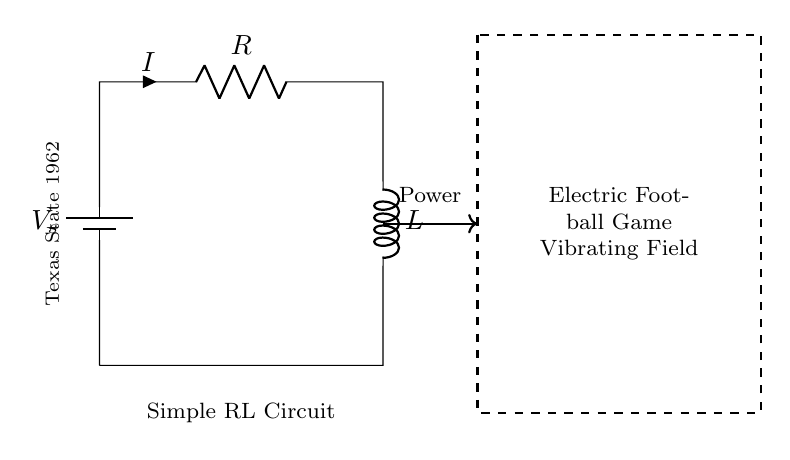What type of components are in this circuit? The circuit contains a resistor and an inductor, which are indicated by the symbols "R" and "L" respectively.
Answer: Resistor and Inductor What is the role of the inductor in this circuit? The inductor stores energy in a magnetic field when current flows through it and reacts to changes in current, which is essential for the vibrating action in the football game.
Answer: Store energy What is the direction of the current in this circuit? The current flows from the positive terminal of the battery through the resistor and inductor and returns to the negative terminal, indicated by the arrow in the circuit diagram showing the current direction.
Answer: Clockwise What happens to the current when the switch is closed? When the switch is closed, the circuit is completed, allowing current to flow, which energizes the inductor. Over time, the current stabilizes to a value determined by the resistance and inductance.
Answer: Current flows What is the primary function of this RL circuit in the electric football game? The primary function of the RL circuit is to control the vibrations of the playing field, creating motion in the game pieces through electromagnetic interaction.
Answer: Control vibrations How does the resistance affect the current in this RL circuit? The resistance, measured in ohms, opposes the flow of current. According to Ohm's Law, an increase in resistance will decrease the overall current in the circuit for a given voltage.
Answer: Decreases current 